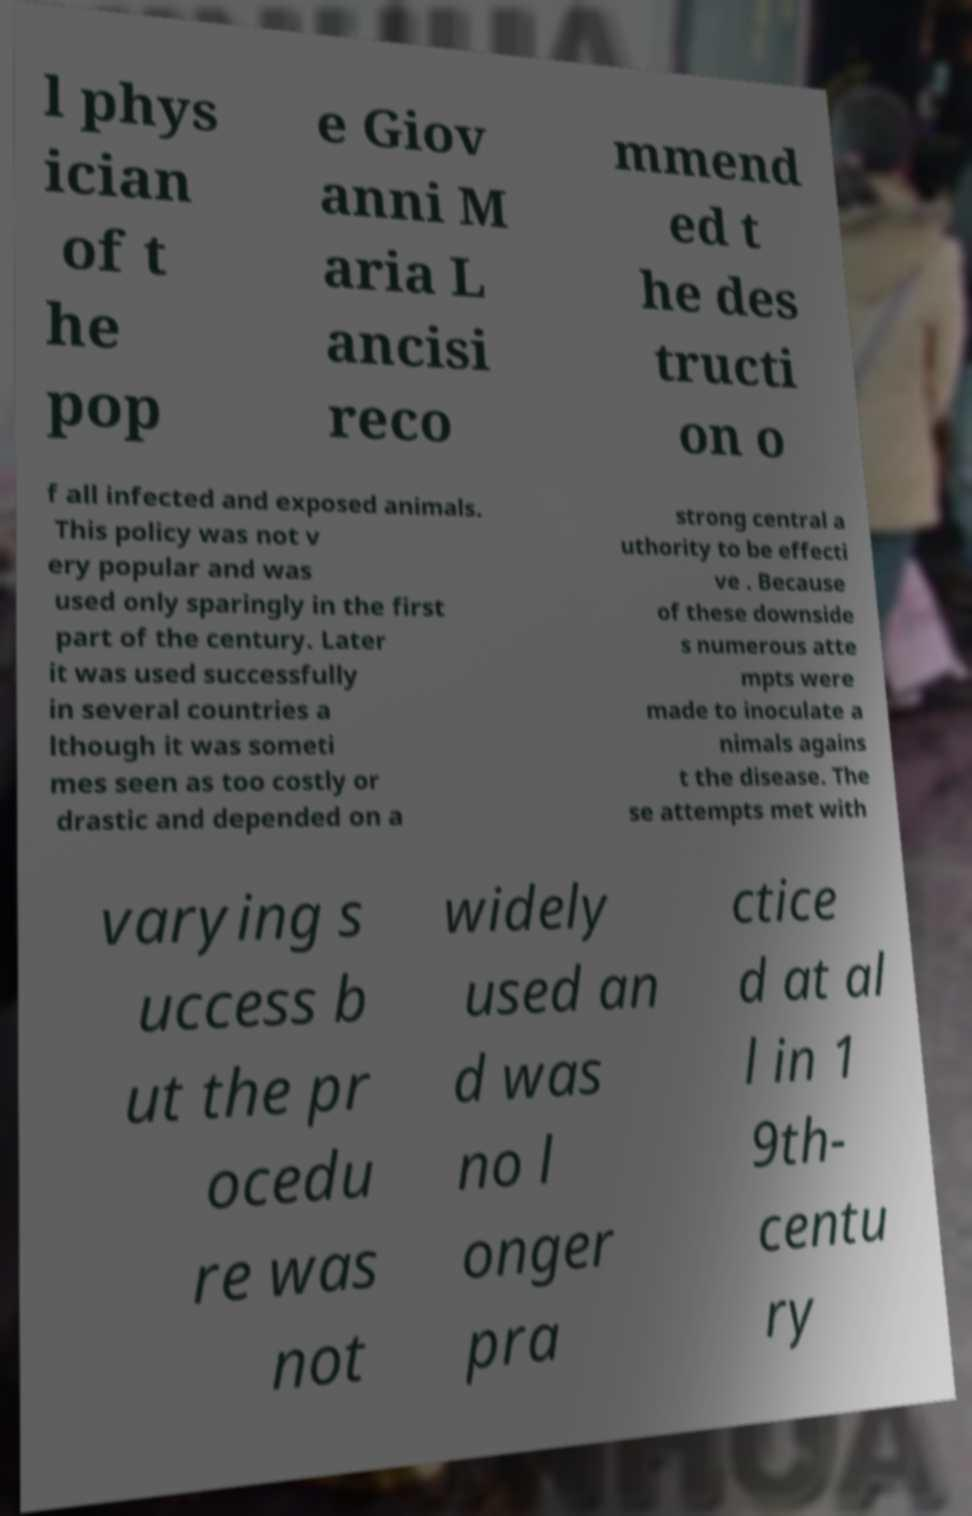For documentation purposes, I need the text within this image transcribed. Could you provide that? l phys ician of t he pop e Giov anni M aria L ancisi reco mmend ed t he des tructi on o f all infected and exposed animals. This policy was not v ery popular and was used only sparingly in the first part of the century. Later it was used successfully in several countries a lthough it was someti mes seen as too costly or drastic and depended on a strong central a uthority to be effecti ve . Because of these downside s numerous atte mpts were made to inoculate a nimals agains t the disease. The se attempts met with varying s uccess b ut the pr ocedu re was not widely used an d was no l onger pra ctice d at al l in 1 9th- centu ry 